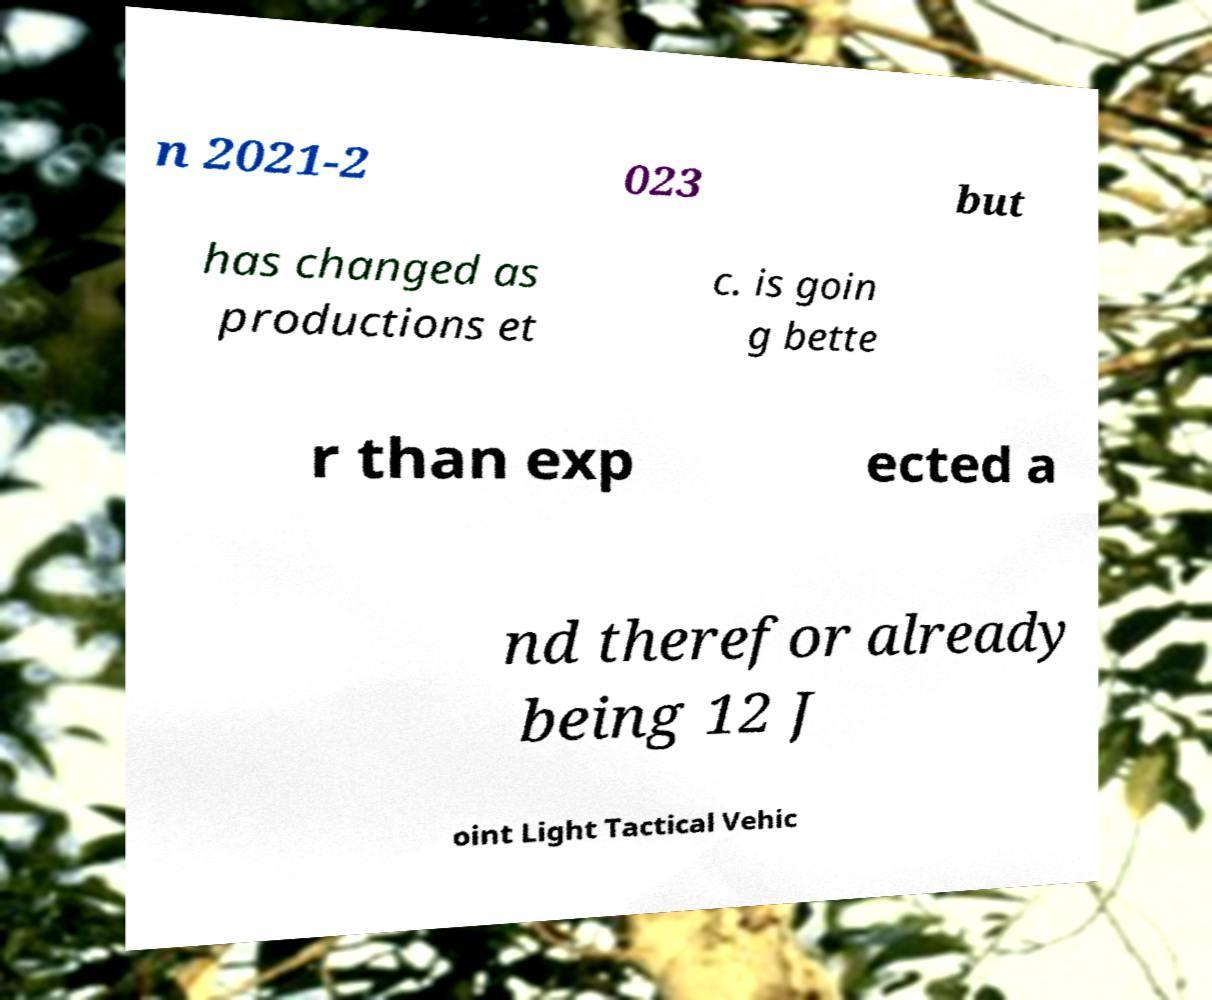For documentation purposes, I need the text within this image transcribed. Could you provide that? n 2021-2 023 but has changed as productions et c. is goin g bette r than exp ected a nd therefor already being 12 J oint Light Tactical Vehic 